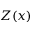<formula> <loc_0><loc_0><loc_500><loc_500>Z ( x )</formula> 